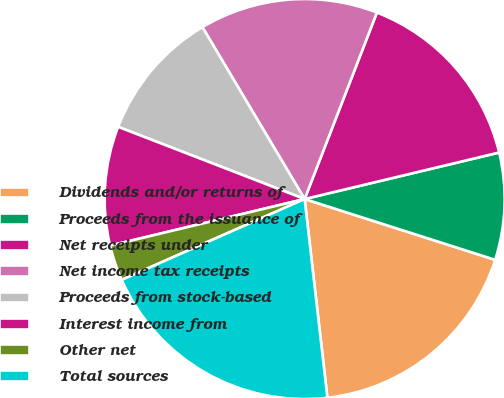Convert chart. <chart><loc_0><loc_0><loc_500><loc_500><pie_chart><fcel>Dividends and/or returns of<fcel>Proceeds from the issuance of<fcel>Net receipts under<fcel>Net income tax receipts<fcel>Proceeds from stock-based<fcel>Interest income from<fcel>Other net<fcel>Total sources<nl><fcel>18.27%<fcel>8.65%<fcel>15.38%<fcel>14.42%<fcel>10.58%<fcel>9.62%<fcel>2.88%<fcel>20.19%<nl></chart> 